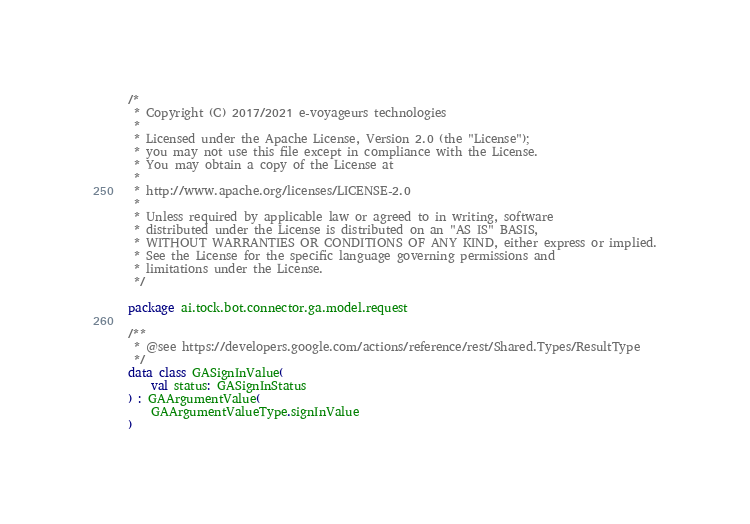<code> <loc_0><loc_0><loc_500><loc_500><_Kotlin_>/*
 * Copyright (C) 2017/2021 e-voyageurs technologies
 *
 * Licensed under the Apache License, Version 2.0 (the "License");
 * you may not use this file except in compliance with the License.
 * You may obtain a copy of the License at
 *
 * http://www.apache.org/licenses/LICENSE-2.0
 *
 * Unless required by applicable law or agreed to in writing, software
 * distributed under the License is distributed on an "AS IS" BASIS,
 * WITHOUT WARRANTIES OR CONDITIONS OF ANY KIND, either express or implied.
 * See the License for the specific language governing permissions and
 * limitations under the License.
 */

package ai.tock.bot.connector.ga.model.request

/**
 * @see https://developers.google.com/actions/reference/rest/Shared.Types/ResultType
 */
data class GASignInValue(
    val status: GASignInStatus
) : GAArgumentValue(
    GAArgumentValueType.signInValue
)
</code> 